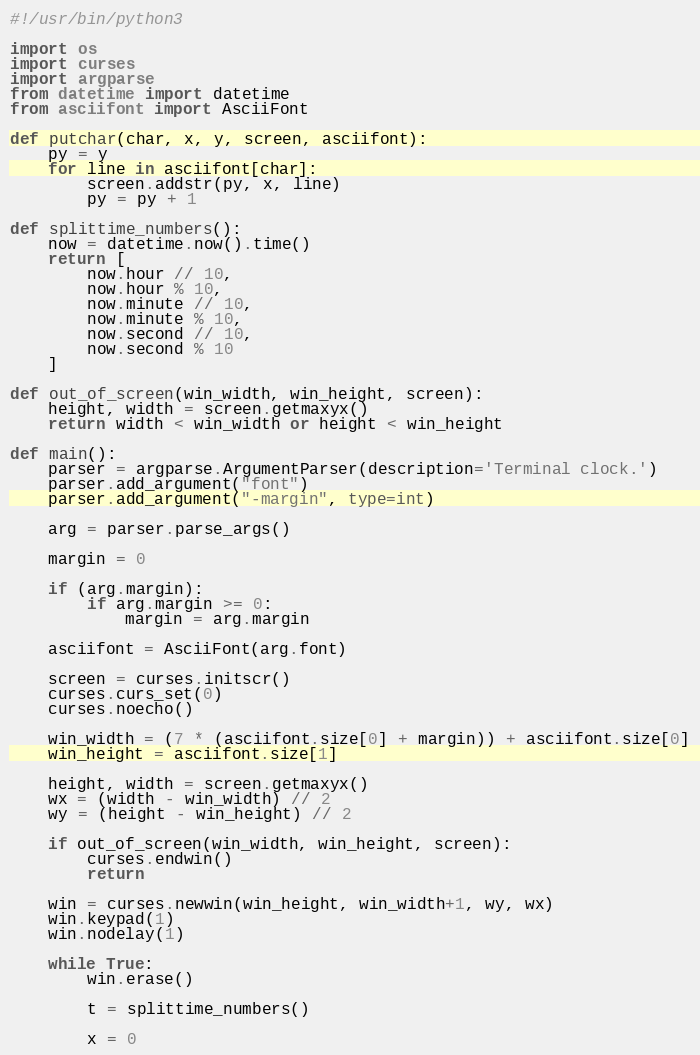Convert code to text. <code><loc_0><loc_0><loc_500><loc_500><_Python_>#!/usr/bin/python3

import os
import curses
import argparse
from datetime import datetime
from asciifont import AsciiFont

def putchar(char, x, y, screen, asciifont):
    py = y
    for line in asciifont[char]:
        screen.addstr(py, x, line)
        py = py + 1

def splittime_numbers():
    now = datetime.now().time()
    return [
        now.hour // 10,
        now.hour % 10,
        now.minute // 10,
        now.minute % 10,
        now.second // 10,
        now.second % 10
    ]

def out_of_screen(win_width, win_height, screen):
    height, width = screen.getmaxyx()
    return width < win_width or height < win_height

def main():
    parser = argparse.ArgumentParser(description='Terminal clock.')
    parser.add_argument("font")
    parser.add_argument("-margin", type=int)

    arg = parser.parse_args()

    margin = 0

    if (arg.margin):
        if arg.margin >= 0:
            margin = arg.margin

    asciifont = AsciiFont(arg.font)

    screen = curses.initscr()
    curses.curs_set(0)
    curses.noecho()

    win_width = (7 * (asciifont.size[0] + margin)) + asciifont.size[0]
    win_height = asciifont.size[1]

    height, width = screen.getmaxyx()
    wx = (width - win_width) // 2
    wy = (height - win_height) // 2

    if out_of_screen(win_width, win_height, screen):
        curses.endwin()
        return

    win = curses.newwin(win_height, win_width+1, wy, wx)
    win.keypad(1)
    win.nodelay(1)

    while True:
        win.erase()

        t = splittime_numbers()

        x = 0</code> 